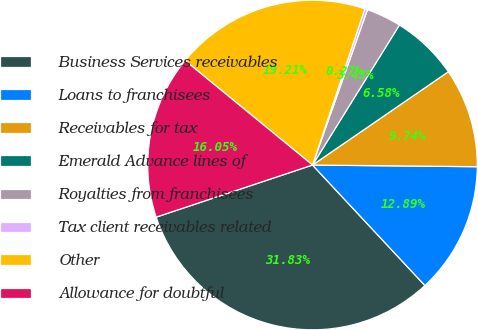Convert chart. <chart><loc_0><loc_0><loc_500><loc_500><pie_chart><fcel>Business Services receivables<fcel>Loans to franchisees<fcel>Receivables for tax<fcel>Emerald Advance lines of<fcel>Royalties from franchisees<fcel>Tax client receivables related<fcel>Other<fcel>Allowance for doubtful<nl><fcel>31.83%<fcel>12.89%<fcel>9.74%<fcel>6.58%<fcel>3.43%<fcel>0.27%<fcel>19.21%<fcel>16.05%<nl></chart> 